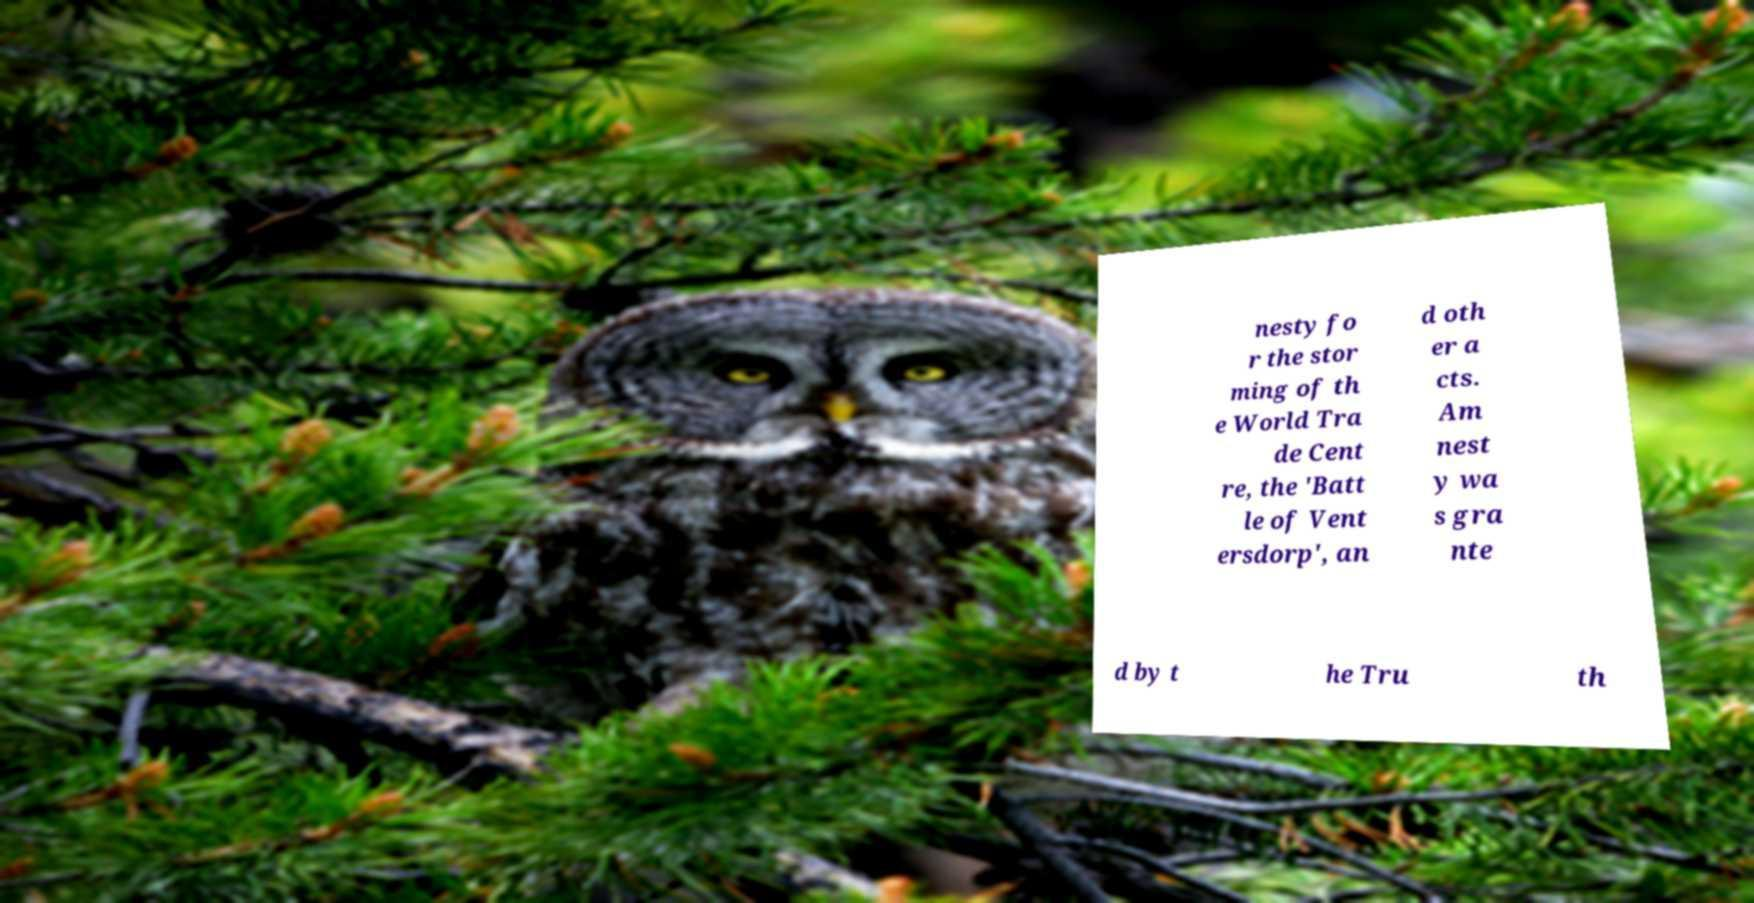For documentation purposes, I need the text within this image transcribed. Could you provide that? nesty fo r the stor ming of th e World Tra de Cent re, the 'Batt le of Vent ersdorp', an d oth er a cts. Am nest y wa s gra nte d by t he Tru th 